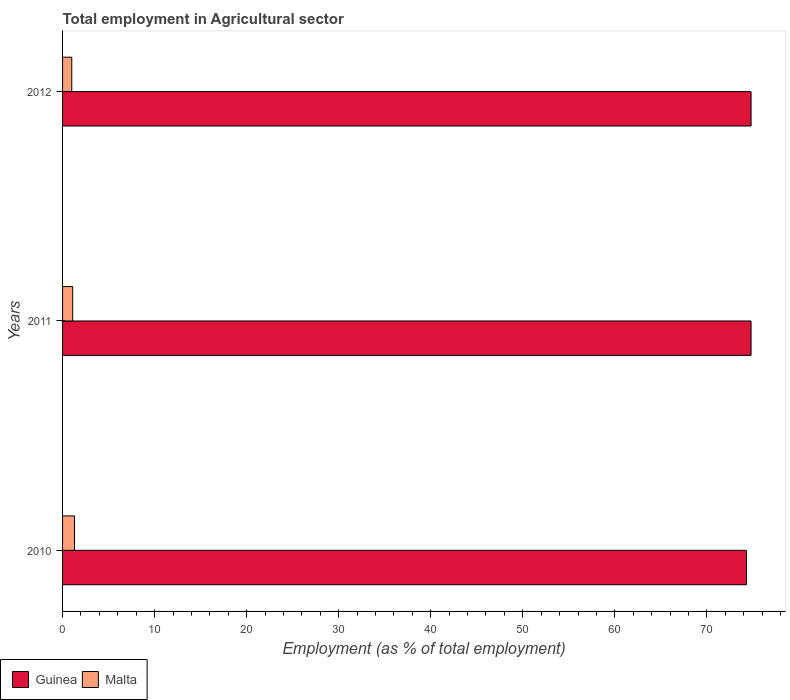How many different coloured bars are there?
Your response must be concise. 2. How many groups of bars are there?
Your response must be concise. 3. In how many cases, is the number of bars for a given year not equal to the number of legend labels?
Provide a short and direct response. 0. What is the employment in agricultural sector in Guinea in 2012?
Your response must be concise. 74.8. Across all years, what is the maximum employment in agricultural sector in Guinea?
Provide a short and direct response. 74.8. In which year was the employment in agricultural sector in Guinea maximum?
Keep it short and to the point. 2011. In which year was the employment in agricultural sector in Malta minimum?
Make the answer very short. 2012. What is the total employment in agricultural sector in Malta in the graph?
Offer a terse response. 3.4. What is the difference between the employment in agricultural sector in Malta in 2010 and that in 2011?
Offer a very short reply. 0.2. What is the difference between the employment in agricultural sector in Guinea in 2010 and the employment in agricultural sector in Malta in 2012?
Your answer should be very brief. 73.3. What is the average employment in agricultural sector in Malta per year?
Your response must be concise. 1.13. In the year 2010, what is the difference between the employment in agricultural sector in Guinea and employment in agricultural sector in Malta?
Provide a short and direct response. 73. In how many years, is the employment in agricultural sector in Malta greater than 34 %?
Offer a very short reply. 0. What is the ratio of the employment in agricultural sector in Guinea in 2010 to that in 2012?
Keep it short and to the point. 0.99. Is the difference between the employment in agricultural sector in Guinea in 2010 and 2012 greater than the difference between the employment in agricultural sector in Malta in 2010 and 2012?
Ensure brevity in your answer.  No. What is the difference between the highest and the second highest employment in agricultural sector in Guinea?
Provide a short and direct response. 0. What is the difference between the highest and the lowest employment in agricultural sector in Malta?
Provide a succinct answer. 0.3. Is the sum of the employment in agricultural sector in Guinea in 2010 and 2011 greater than the maximum employment in agricultural sector in Malta across all years?
Keep it short and to the point. Yes. What does the 1st bar from the top in 2010 represents?
Offer a very short reply. Malta. What does the 2nd bar from the bottom in 2011 represents?
Offer a very short reply. Malta. How many bars are there?
Offer a very short reply. 6. Are all the bars in the graph horizontal?
Your answer should be compact. Yes. Are the values on the major ticks of X-axis written in scientific E-notation?
Give a very brief answer. No. How are the legend labels stacked?
Give a very brief answer. Horizontal. What is the title of the graph?
Provide a succinct answer. Total employment in Agricultural sector. Does "Timor-Leste" appear as one of the legend labels in the graph?
Your response must be concise. No. What is the label or title of the X-axis?
Provide a succinct answer. Employment (as % of total employment). What is the Employment (as % of total employment) of Guinea in 2010?
Keep it short and to the point. 74.3. What is the Employment (as % of total employment) of Malta in 2010?
Offer a very short reply. 1.3. What is the Employment (as % of total employment) in Guinea in 2011?
Give a very brief answer. 74.8. What is the Employment (as % of total employment) of Malta in 2011?
Your answer should be very brief. 1.1. What is the Employment (as % of total employment) in Guinea in 2012?
Offer a terse response. 74.8. What is the Employment (as % of total employment) of Malta in 2012?
Provide a short and direct response. 1. Across all years, what is the maximum Employment (as % of total employment) of Guinea?
Your answer should be very brief. 74.8. Across all years, what is the maximum Employment (as % of total employment) of Malta?
Make the answer very short. 1.3. Across all years, what is the minimum Employment (as % of total employment) in Guinea?
Give a very brief answer. 74.3. What is the total Employment (as % of total employment) of Guinea in the graph?
Offer a very short reply. 223.9. What is the difference between the Employment (as % of total employment) in Guinea in 2010 and that in 2011?
Offer a terse response. -0.5. What is the difference between the Employment (as % of total employment) in Malta in 2010 and that in 2011?
Your answer should be compact. 0.2. What is the difference between the Employment (as % of total employment) of Guinea in 2011 and that in 2012?
Offer a terse response. 0. What is the difference between the Employment (as % of total employment) of Malta in 2011 and that in 2012?
Your answer should be very brief. 0.1. What is the difference between the Employment (as % of total employment) of Guinea in 2010 and the Employment (as % of total employment) of Malta in 2011?
Make the answer very short. 73.2. What is the difference between the Employment (as % of total employment) in Guinea in 2010 and the Employment (as % of total employment) in Malta in 2012?
Keep it short and to the point. 73.3. What is the difference between the Employment (as % of total employment) of Guinea in 2011 and the Employment (as % of total employment) of Malta in 2012?
Make the answer very short. 73.8. What is the average Employment (as % of total employment) of Guinea per year?
Make the answer very short. 74.63. What is the average Employment (as % of total employment) of Malta per year?
Keep it short and to the point. 1.13. In the year 2011, what is the difference between the Employment (as % of total employment) of Guinea and Employment (as % of total employment) of Malta?
Offer a very short reply. 73.7. In the year 2012, what is the difference between the Employment (as % of total employment) in Guinea and Employment (as % of total employment) in Malta?
Your answer should be compact. 73.8. What is the ratio of the Employment (as % of total employment) of Guinea in 2010 to that in 2011?
Provide a succinct answer. 0.99. What is the ratio of the Employment (as % of total employment) in Malta in 2010 to that in 2011?
Give a very brief answer. 1.18. What is the ratio of the Employment (as % of total employment) in Guinea in 2010 to that in 2012?
Offer a terse response. 0.99. What is the ratio of the Employment (as % of total employment) in Malta in 2010 to that in 2012?
Make the answer very short. 1.3. What is the ratio of the Employment (as % of total employment) in Guinea in 2011 to that in 2012?
Your answer should be compact. 1. What is the difference between the highest and the second highest Employment (as % of total employment) of Malta?
Your answer should be compact. 0.2. What is the difference between the highest and the lowest Employment (as % of total employment) of Guinea?
Provide a short and direct response. 0.5. 